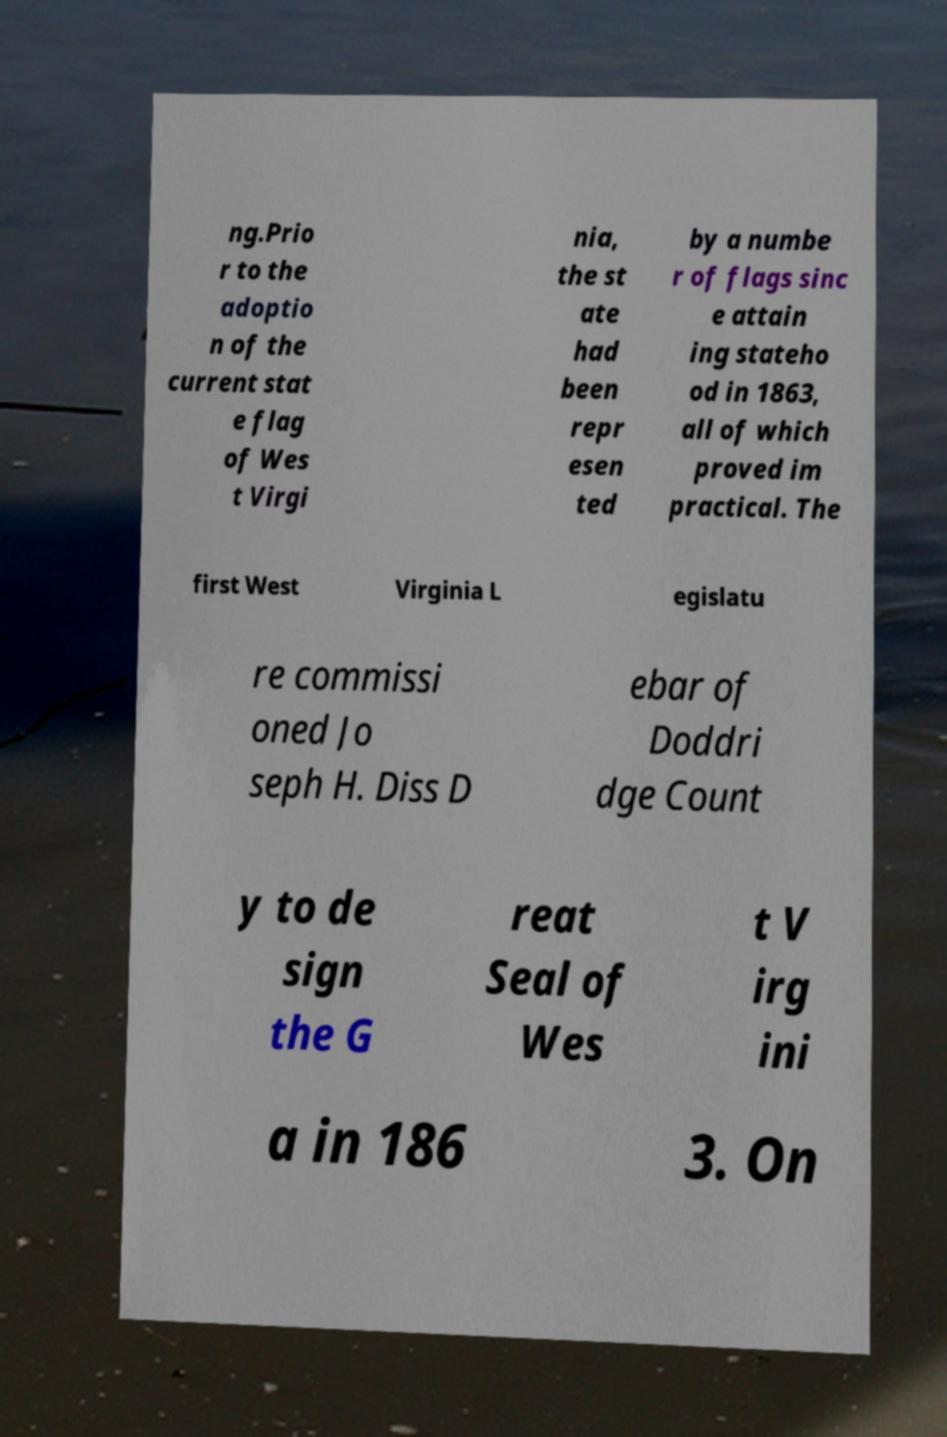Could you assist in decoding the text presented in this image and type it out clearly? ng.Prio r to the adoptio n of the current stat e flag of Wes t Virgi nia, the st ate had been repr esen ted by a numbe r of flags sinc e attain ing stateho od in 1863, all of which proved im practical. The first West Virginia L egislatu re commissi oned Jo seph H. Diss D ebar of Doddri dge Count y to de sign the G reat Seal of Wes t V irg ini a in 186 3. On 